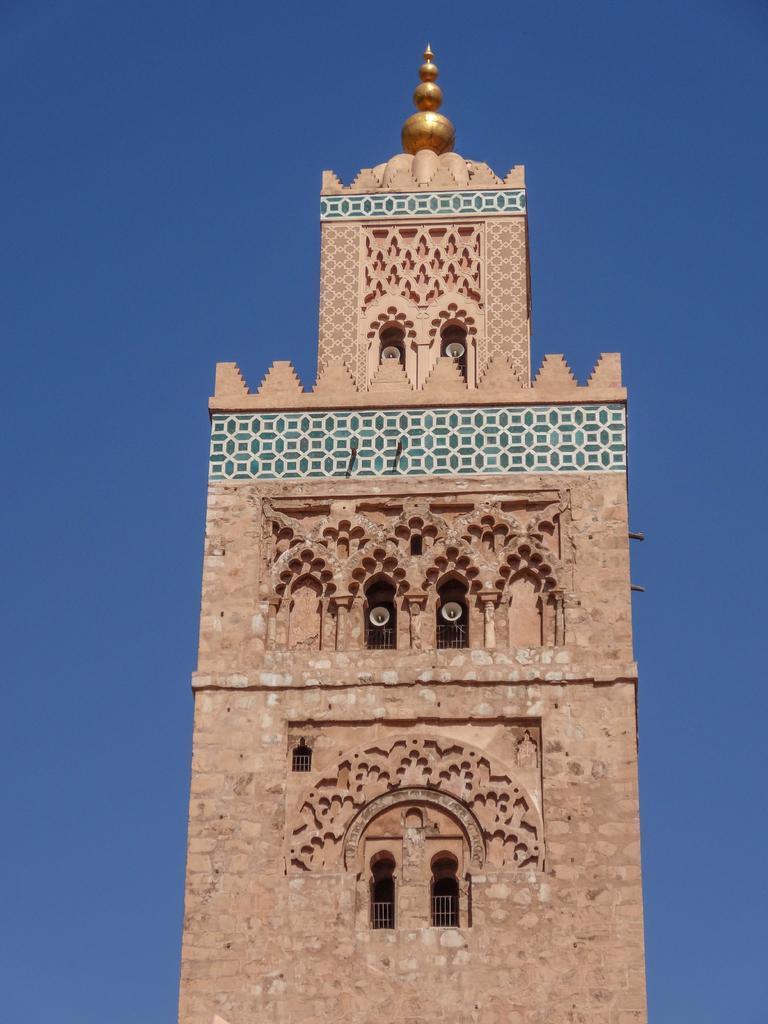How would you summarize this image in a sentence or two? In this image I see a monument which is of brown, white and green in color and I see a golden color thing over here. In the background I see the blue sky. 